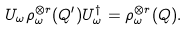<formula> <loc_0><loc_0><loc_500><loc_500>U _ { \omega } \rho _ { \omega } ^ { \otimes r } ( Q ^ { \prime } ) U _ { \omega } ^ { \dagger } = \rho _ { \omega } ^ { \otimes r } ( Q ) .</formula> 